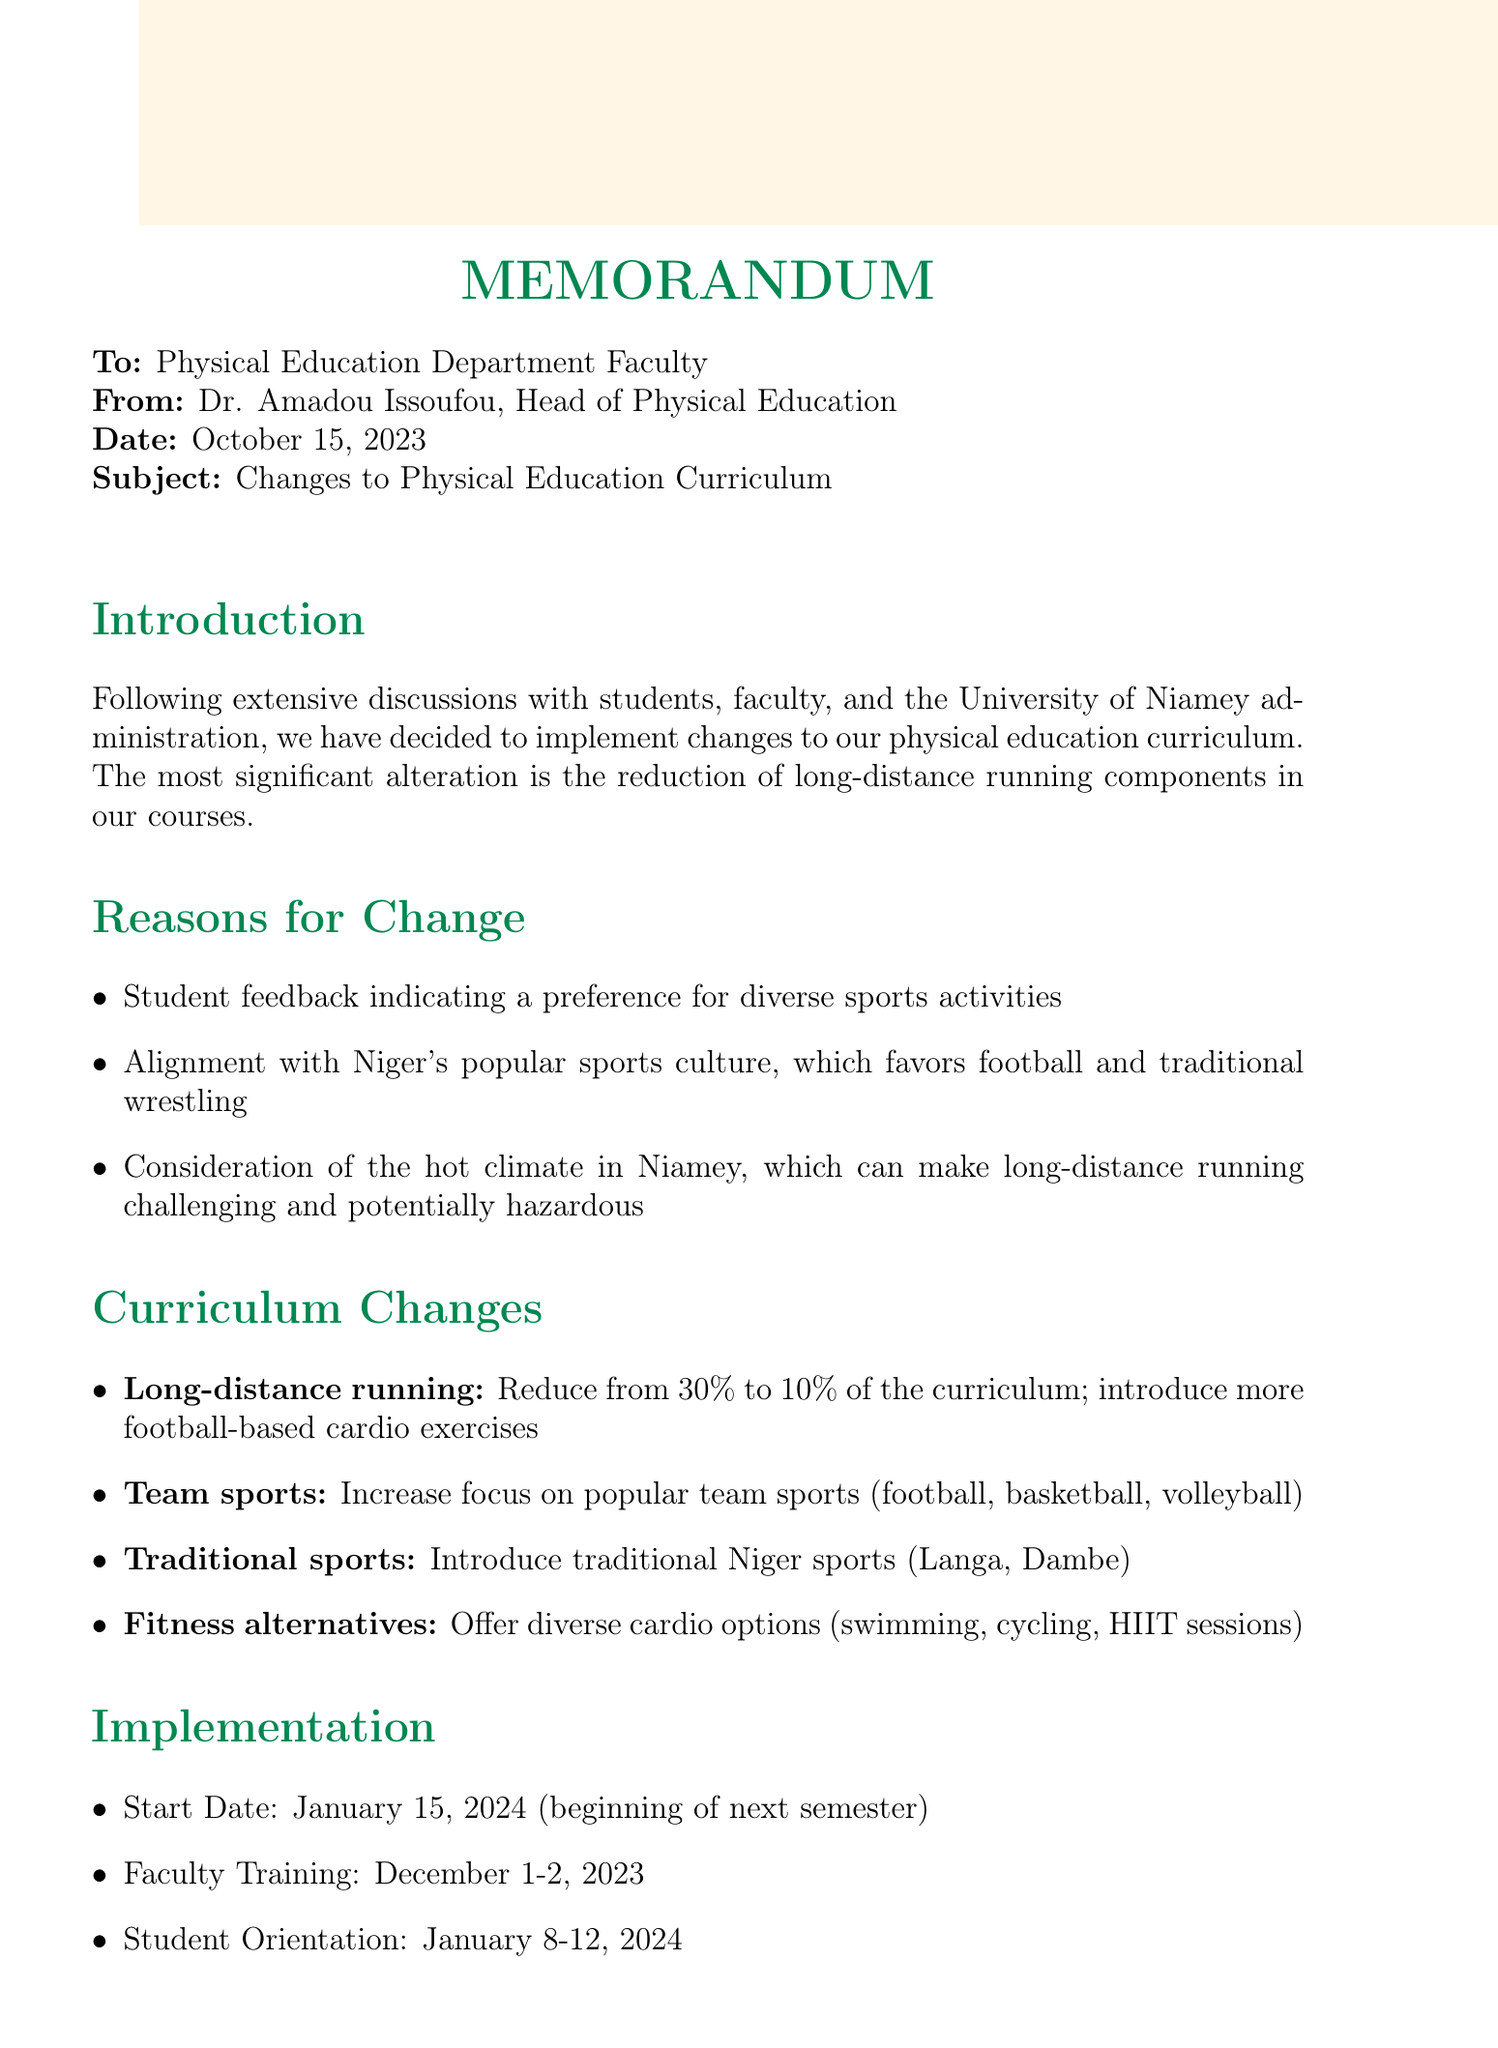what is the date of the memo? The date of the memo is clearly stated in the header section of the document.
Answer: October 15, 2023 who is the author of the memo? The author's name is mentioned in the "From" section of the memo.
Answer: Dr. Amadou Issoufou what percentage of the curriculum is long-distance running reduced to? The reduction percentage is specified in the curriculum changes section of the document.
Answer: 10% what is one reason for changing the curriculum? The document lists multiple reasons for the changes in the "Reasons for Change" section.
Answer: Student feedback indicating a preference for diverse sports activities when does the new curriculum start? The start date for the implementation of the new curriculum is noted in the implementation section.
Answer: January 15, 2024 what type of training session is scheduled for faculty? The type of training session is detailed in the implementation section of the memo.
Answer: Faculty training on new curriculum components which traditional sport is included in the new curriculum? The specific traditional sport is mentioned in the curriculum changes section.
Answer: Langa (traditional wrestling) what is expected to improve through diverse physical activities? The outcomes of the new curriculum are outlined in the expected outcomes section.
Answer: Overall fitness levels 